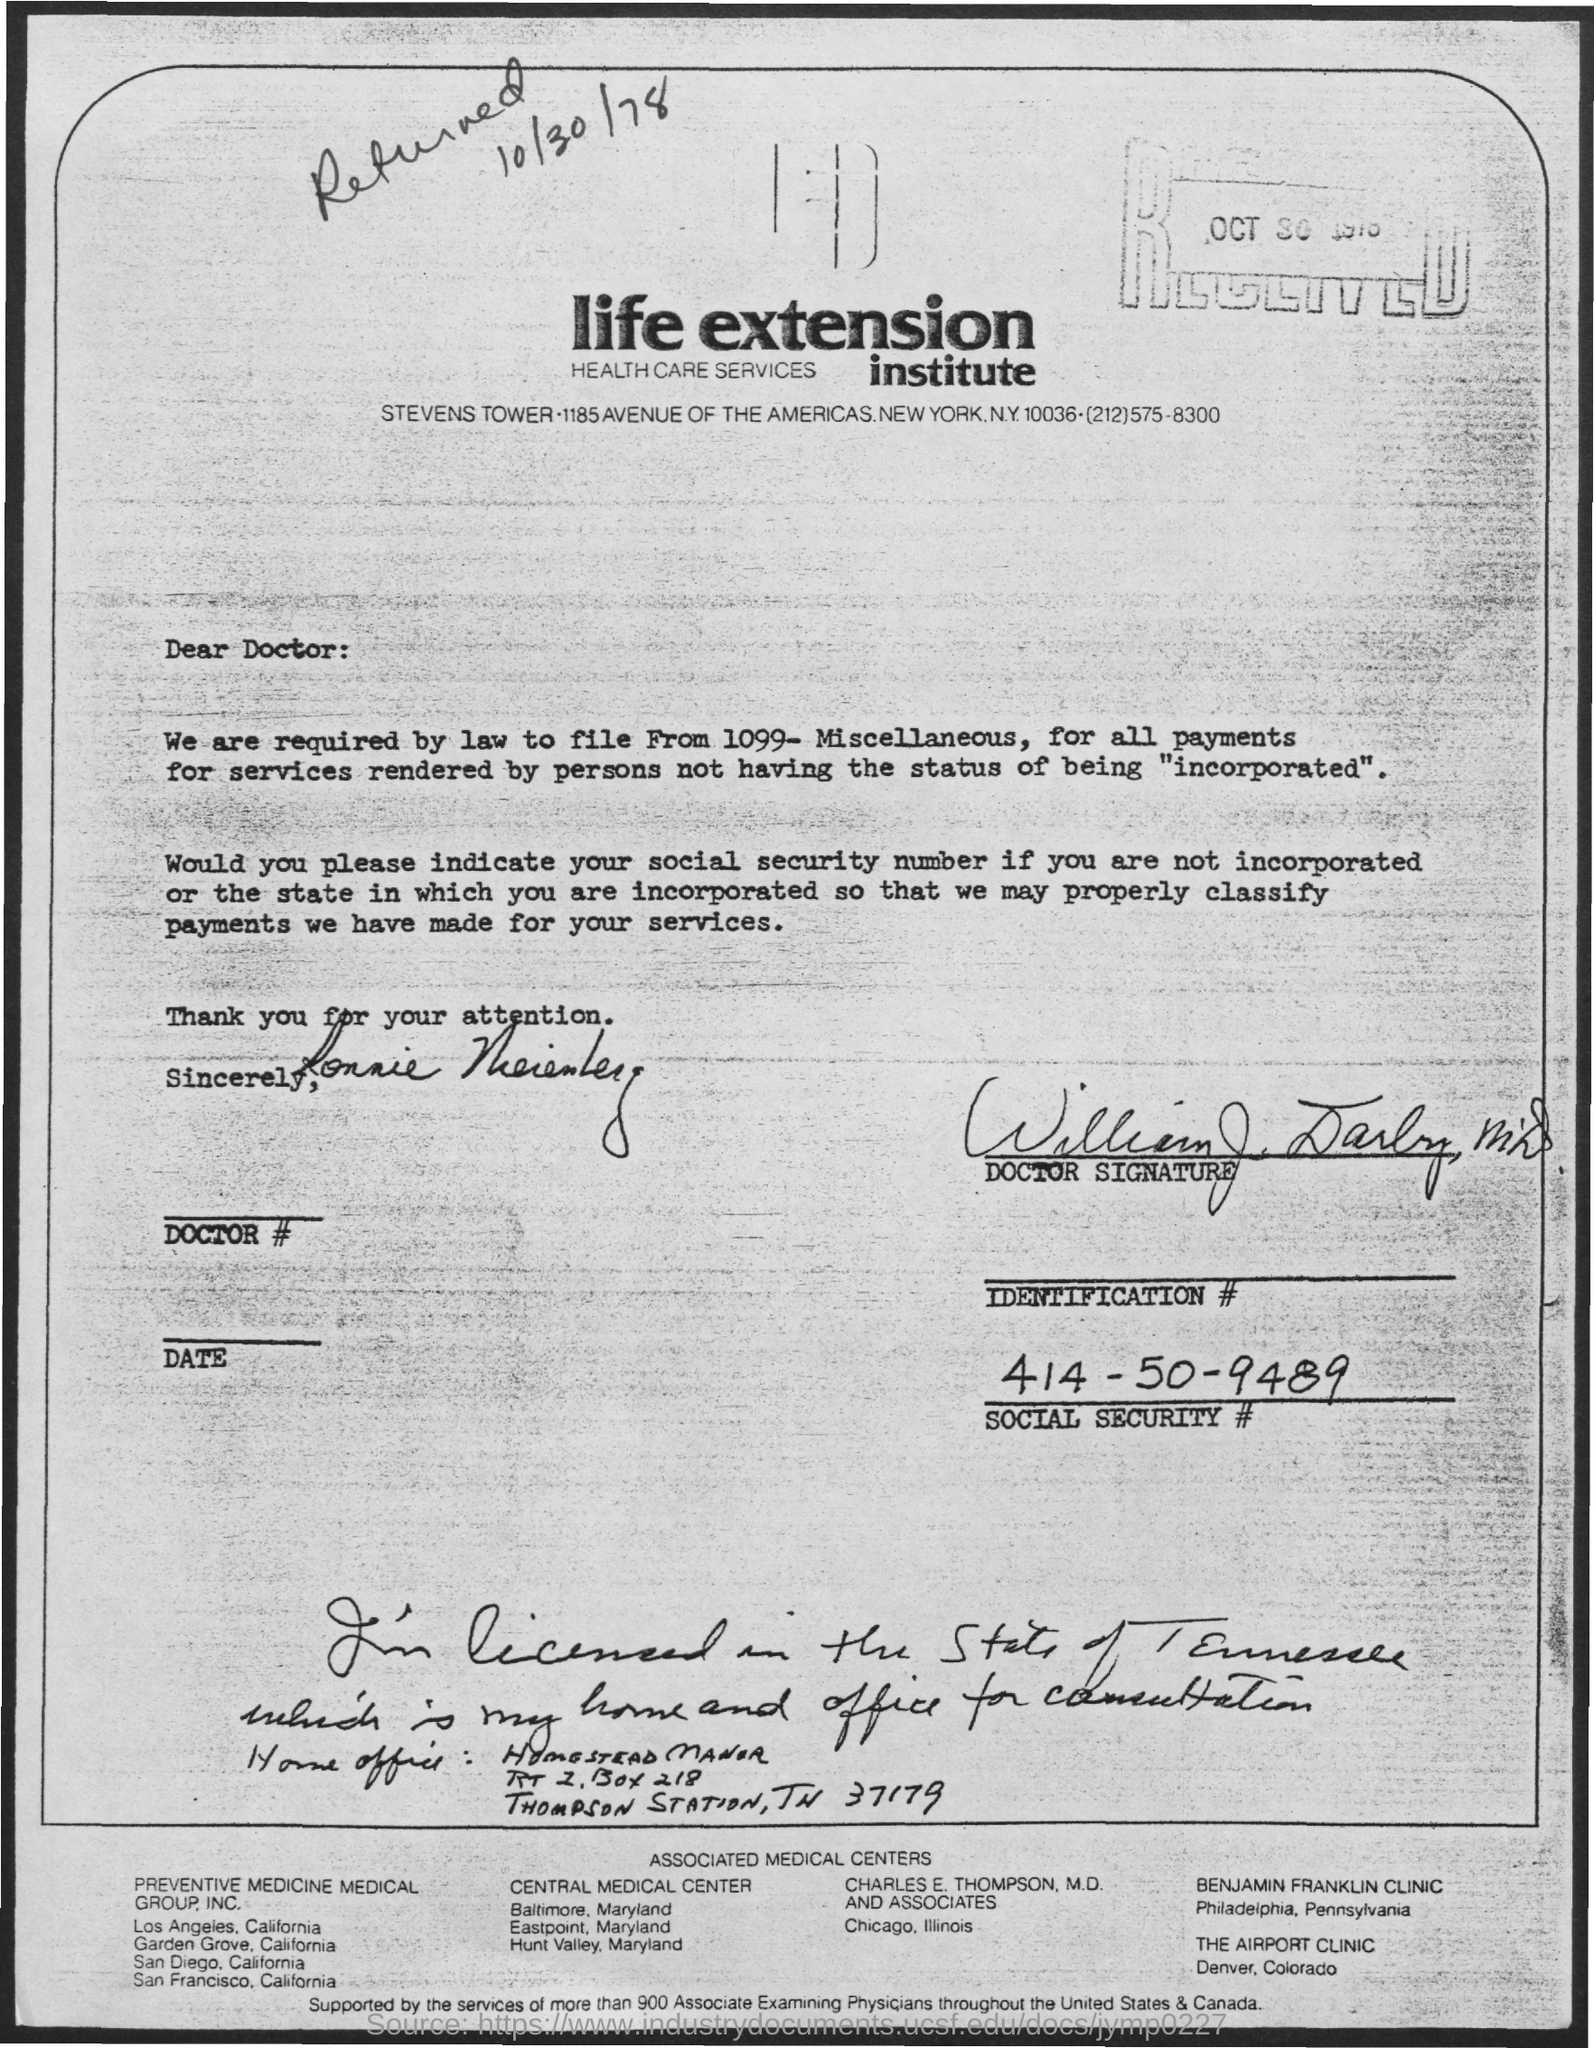What is the Social Security #?
Make the answer very short. 414-50-9489. 